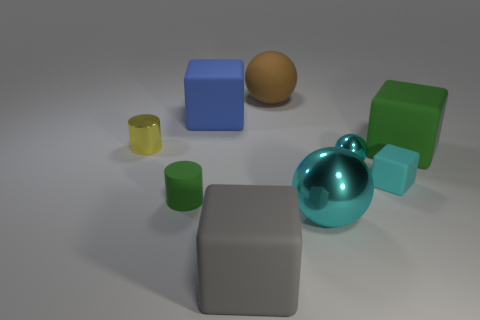What is the size of the rubber cube that is both behind the large metallic ball and on the left side of the rubber sphere?
Your answer should be compact. Large. What is the shape of the blue thing that is the same material as the cyan cube?
Your answer should be very brief. Cube. There is a tiny matte thing that is the same color as the large metallic object; what is its shape?
Ensure brevity in your answer.  Cube. What is the size of the cyan object that is the same material as the green cylinder?
Make the answer very short. Small. The rubber block that is the same color as the small sphere is what size?
Ensure brevity in your answer.  Small. What is the color of the rubber cylinder?
Your response must be concise. Green. What is the size of the cylinder behind the cylinder right of the small metal cylinder on the left side of the gray rubber cube?
Offer a terse response. Small. How many other things are the same shape as the large cyan metal thing?
Your answer should be compact. 2. The rubber thing that is both to the left of the large gray rubber object and in front of the big blue thing is what color?
Make the answer very short. Green. Do the big matte cube on the right side of the big cyan shiny ball and the small matte cylinder have the same color?
Offer a very short reply. Yes. 